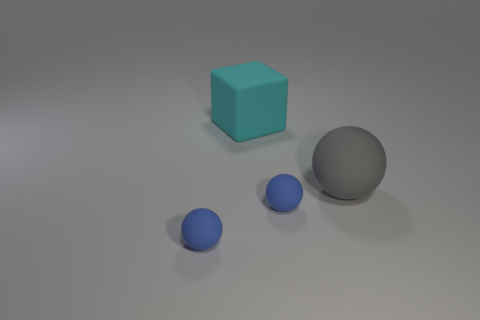The ball that is both in front of the big gray matte thing and to the right of the cyan cube is what color?
Provide a succinct answer. Blue. Are there more big gray matte objects to the left of the big gray thing than blue balls on the right side of the block?
Offer a very short reply. No. There is a gray ball that is made of the same material as the cyan object; what size is it?
Offer a very short reply. Large. What number of tiny blue matte objects are on the right side of the small blue matte object to the left of the cube?
Your response must be concise. 1. Are there any other big cyan objects that have the same shape as the cyan object?
Make the answer very short. No. What color is the tiny matte object that is left of the matte thing behind the gray rubber ball?
Keep it short and to the point. Blue. Is the number of gray things greater than the number of blue matte balls?
Make the answer very short. No. How many gray rubber objects are the same size as the rubber cube?
Provide a short and direct response. 1. Does the large ball have the same material as the large thing that is to the left of the gray rubber sphere?
Make the answer very short. Yes. Is the number of large matte blocks less than the number of large things?
Your response must be concise. Yes. 